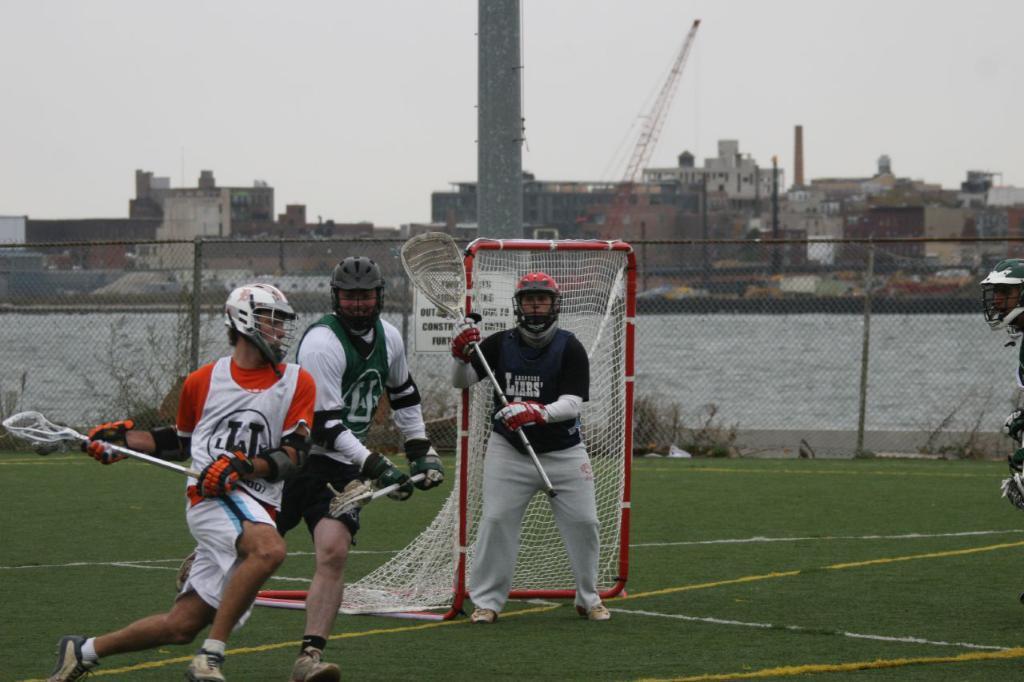Could you give a brief overview of what you see in this image? In the center of the image we can see persons on the grass. In the background we can see net, fencing, water, buildings, pillar and sky. 